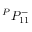Convert formula to latex. <formula><loc_0><loc_0><loc_500><loc_500>{ } ^ { P } { P } _ { 1 { 1 } } ^ { - }</formula> 